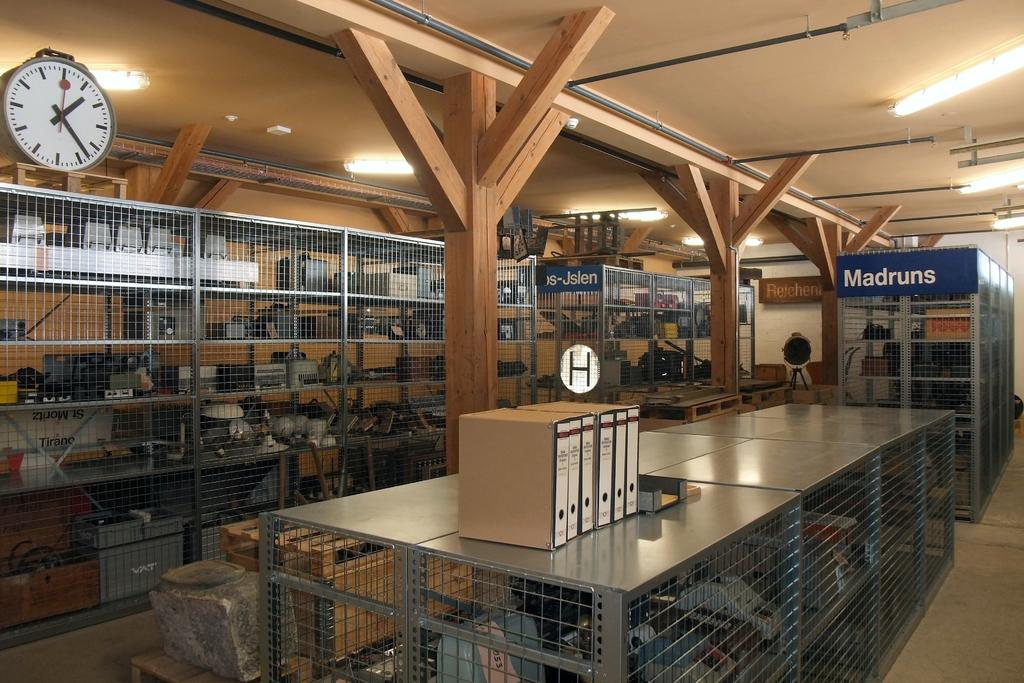<image>
Share a concise interpretation of the image provided. a madruns sign that is in some kind of port area 